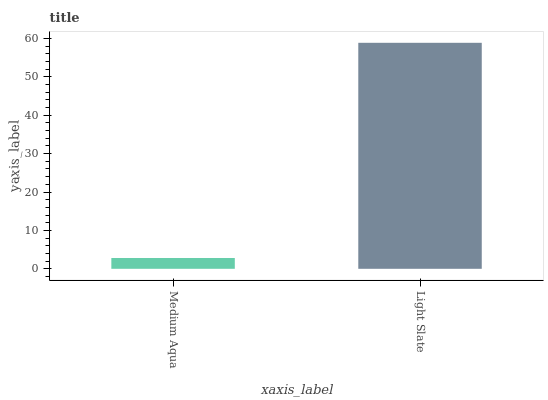Is Medium Aqua the minimum?
Answer yes or no. Yes. Is Light Slate the maximum?
Answer yes or no. Yes. Is Light Slate the minimum?
Answer yes or no. No. Is Light Slate greater than Medium Aqua?
Answer yes or no. Yes. Is Medium Aqua less than Light Slate?
Answer yes or no. Yes. Is Medium Aqua greater than Light Slate?
Answer yes or no. No. Is Light Slate less than Medium Aqua?
Answer yes or no. No. Is Light Slate the high median?
Answer yes or no. Yes. Is Medium Aqua the low median?
Answer yes or no. Yes. Is Medium Aqua the high median?
Answer yes or no. No. Is Light Slate the low median?
Answer yes or no. No. 